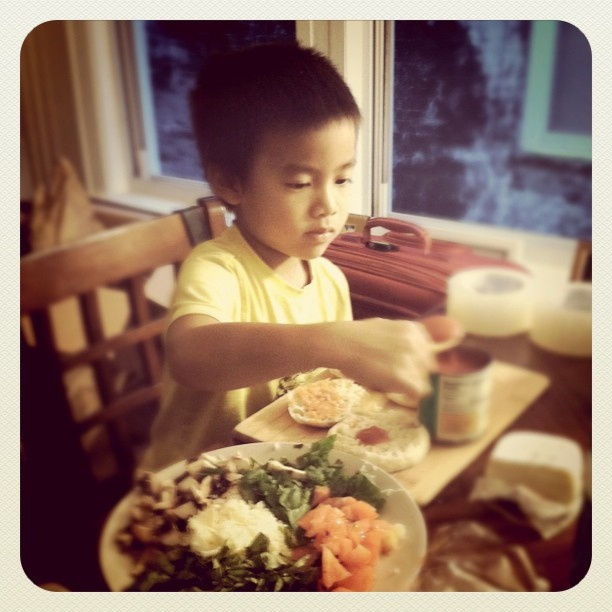Describe the objects in this image and their specific colors. I can see dining table in ivory, tan, and maroon tones, people in ivory, black, brown, khaki, and maroon tones, chair in ivory, black, maroon, brown, and tan tones, dining table in ivory, maroon, brown, and black tones, and suitcase in ivory, brown, maroon, and salmon tones in this image. 